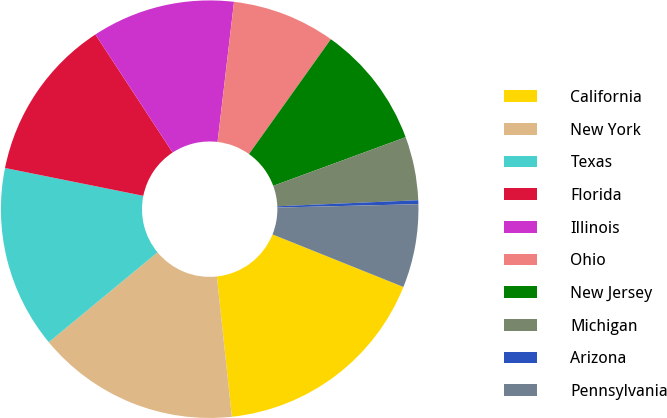<chart> <loc_0><loc_0><loc_500><loc_500><pie_chart><fcel>California<fcel>New York<fcel>Texas<fcel>Florida<fcel>Illinois<fcel>Ohio<fcel>New Jersey<fcel>Michigan<fcel>Arizona<fcel>Pennsylvania<nl><fcel>17.23%<fcel>15.7%<fcel>14.16%<fcel>12.62%<fcel>11.08%<fcel>8.0%<fcel>9.54%<fcel>4.92%<fcel>0.3%<fcel>6.46%<nl></chart> 